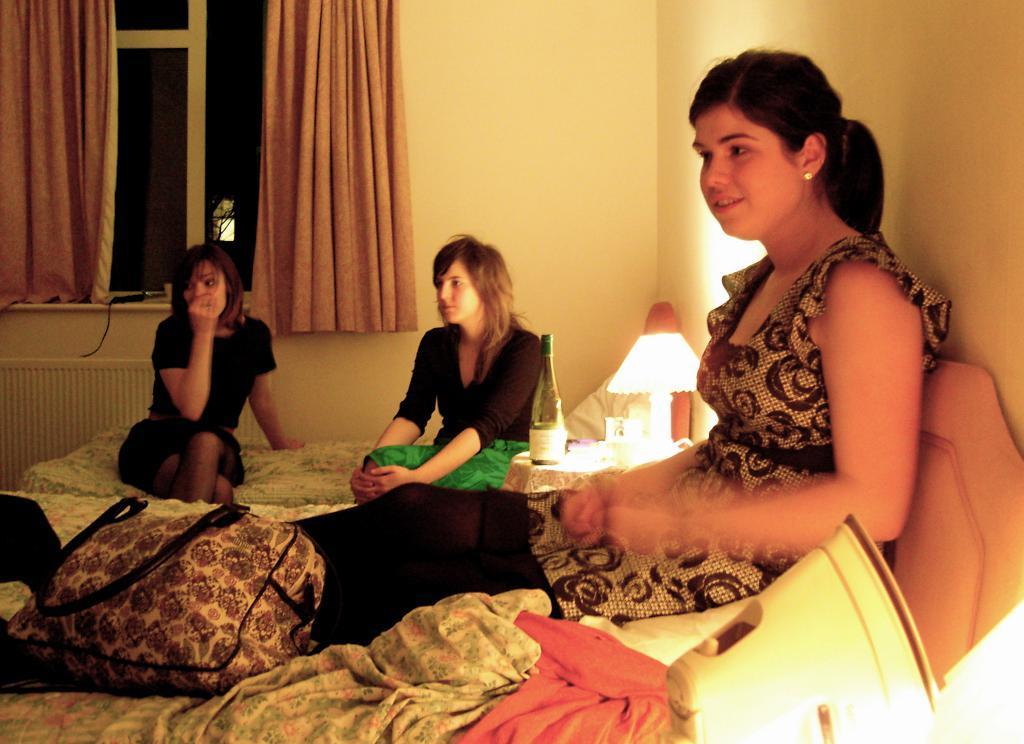Could you give a brief overview of what you see in this image? In this image there are three women sitting on the beds, on the beds there are blankets and there is a bag, beside the bed there is an iron box, in between the beds there is a lamp and a champagne bottle on a table, in the background of the image there are walls and there are curtains on the windows and there is a room heater. 